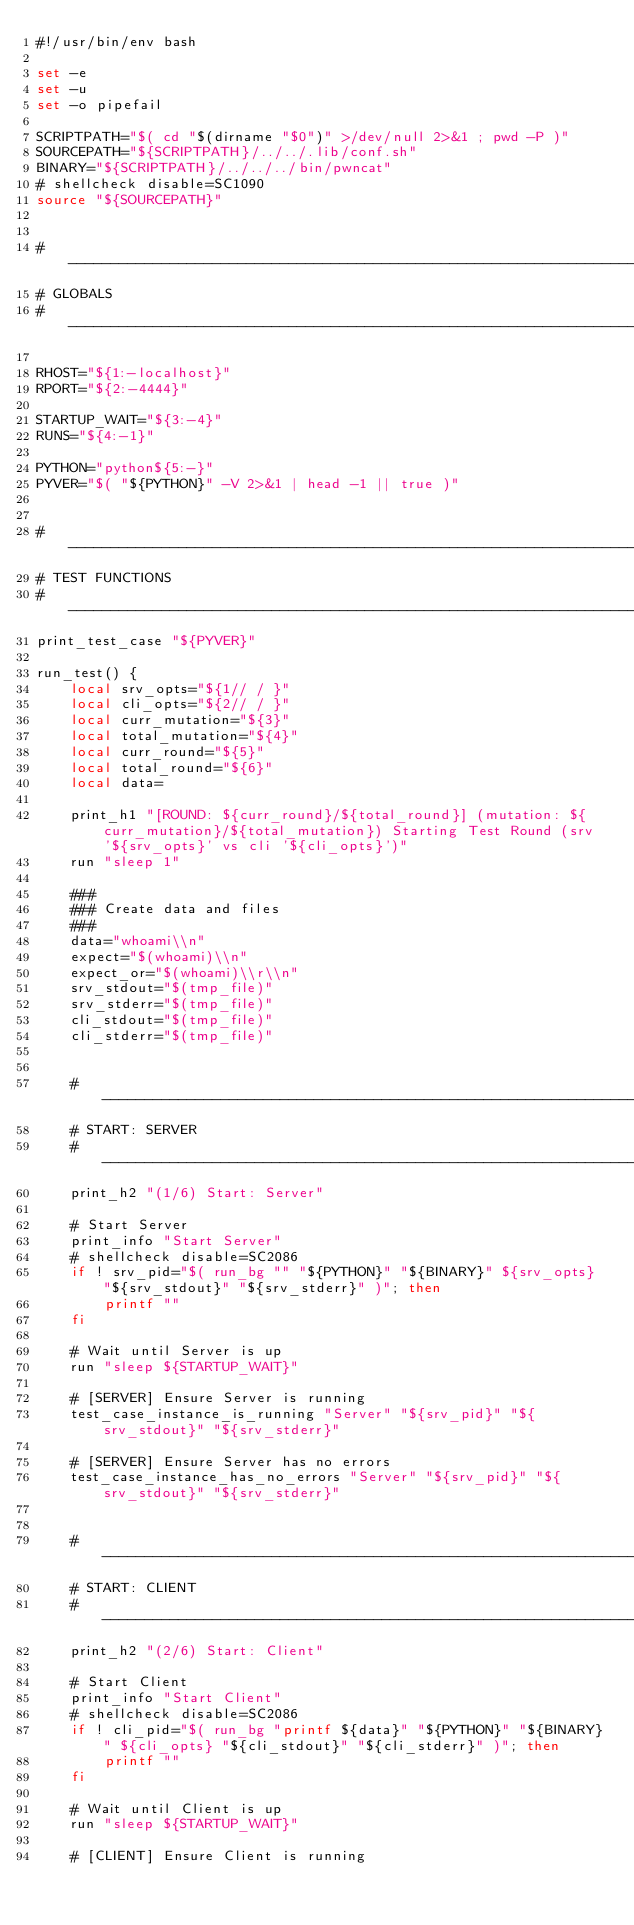<code> <loc_0><loc_0><loc_500><loc_500><_Bash_>#!/usr/bin/env bash

set -e
set -u
set -o pipefail

SCRIPTPATH="$( cd "$(dirname "$0")" >/dev/null 2>&1 ; pwd -P )"
SOURCEPATH="${SCRIPTPATH}/../../.lib/conf.sh"
BINARY="${SCRIPTPATH}/../../../bin/pwncat"
# shellcheck disable=SC1090
source "${SOURCEPATH}"


# -------------------------------------------------------------------------------------------------
# GLOBALS
# -------------------------------------------------------------------------------------------------

RHOST="${1:-localhost}"
RPORT="${2:-4444}"

STARTUP_WAIT="${3:-4}"
RUNS="${4:-1}"

PYTHON="python${5:-}"
PYVER="$( "${PYTHON}" -V 2>&1 | head -1 || true )"


# -------------------------------------------------------------------------------------------------
# TEST FUNCTIONS
# -------------------------------------------------------------------------------------------------
print_test_case "${PYVER}"

run_test() {
	local srv_opts="${1// / }"
	local cli_opts="${2// / }"
	local curr_mutation="${3}"
	local total_mutation="${4}"
	local curr_round="${5}"
	local total_round="${6}"
	local data=

	print_h1 "[ROUND: ${curr_round}/${total_round}] (mutation: ${curr_mutation}/${total_mutation}) Starting Test Round (srv '${srv_opts}' vs cli '${cli_opts}')"
	run "sleep 1"

	###
	### Create data and files
	###
	data="whoami\\n"
	expect="$(whoami)\\n"
	expect_or="$(whoami)\\r\\n"
	srv_stdout="$(tmp_file)"
	srv_stderr="$(tmp_file)"
	cli_stdout="$(tmp_file)"
	cli_stderr="$(tmp_file)"


	# --------------------------------------------------------------------------------
	# START: SERVER
	# --------------------------------------------------------------------------------
	print_h2 "(1/6) Start: Server"

	# Start Server
	print_info "Start Server"
	# shellcheck disable=SC2086
	if ! srv_pid="$( run_bg "" "${PYTHON}" "${BINARY}" ${srv_opts} "${srv_stdout}" "${srv_stderr}" )"; then
		printf ""
	fi

	# Wait until Server is up
	run "sleep ${STARTUP_WAIT}"

	# [SERVER] Ensure Server is running
	test_case_instance_is_running "Server" "${srv_pid}" "${srv_stdout}" "${srv_stderr}"

	# [SERVER] Ensure Server has no errors
	test_case_instance_has_no_errors "Server" "${srv_pid}" "${srv_stdout}" "${srv_stderr}"


	# --------------------------------------------------------------------------------
	# START: CLIENT
	# --------------------------------------------------------------------------------
	print_h2 "(2/6) Start: Client"

	# Start Client
	print_info "Start Client"
	# shellcheck disable=SC2086
	if ! cli_pid="$( run_bg "printf ${data}" "${PYTHON}" "${BINARY}" ${cli_opts} "${cli_stdout}" "${cli_stderr}" )"; then
		printf ""
	fi

	# Wait until Client is up
	run "sleep ${STARTUP_WAIT}"

	# [CLIENT] Ensure Client is running</code> 